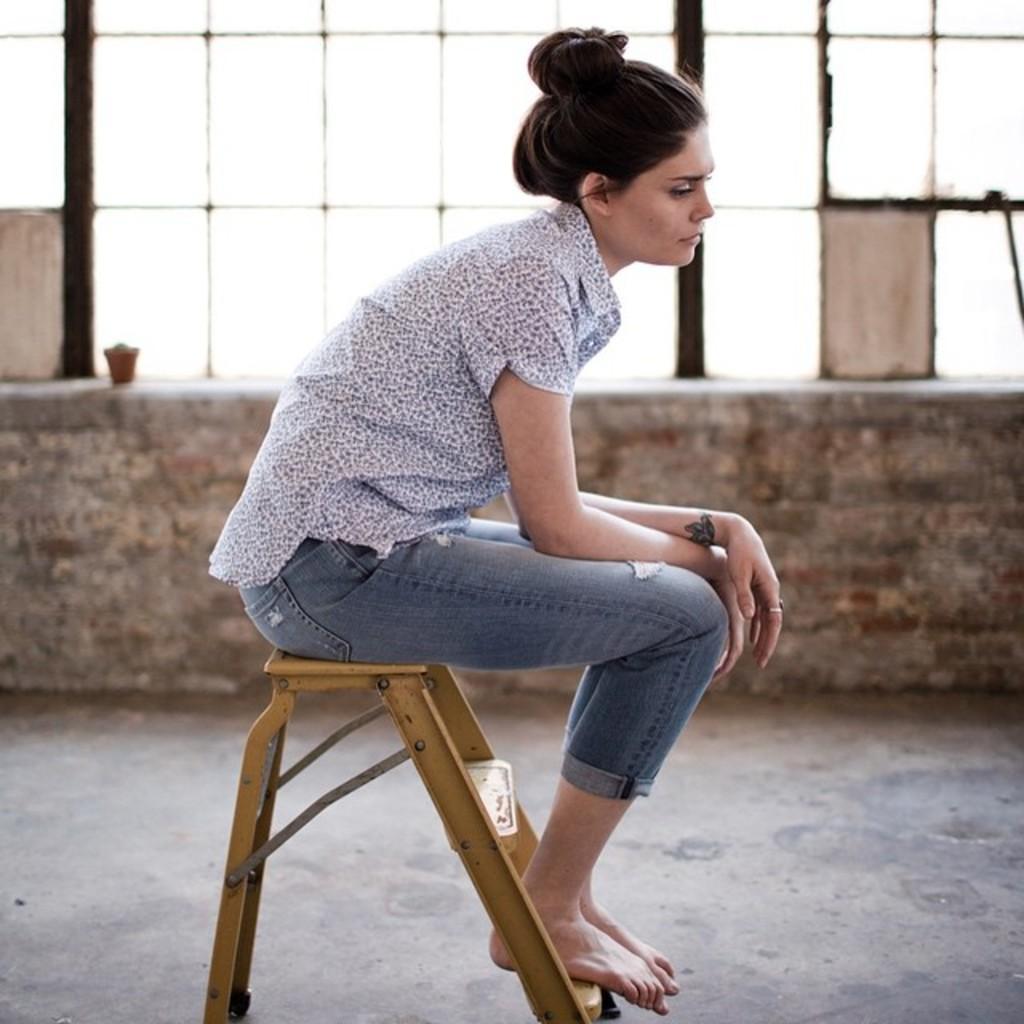In one or two sentences, can you explain what this image depicts? In this image there is a woman sitting, there is an object towards the bottom of the image, the object looks like a wooden stool, there is a wall, there is an object on the wall, there are windows. 